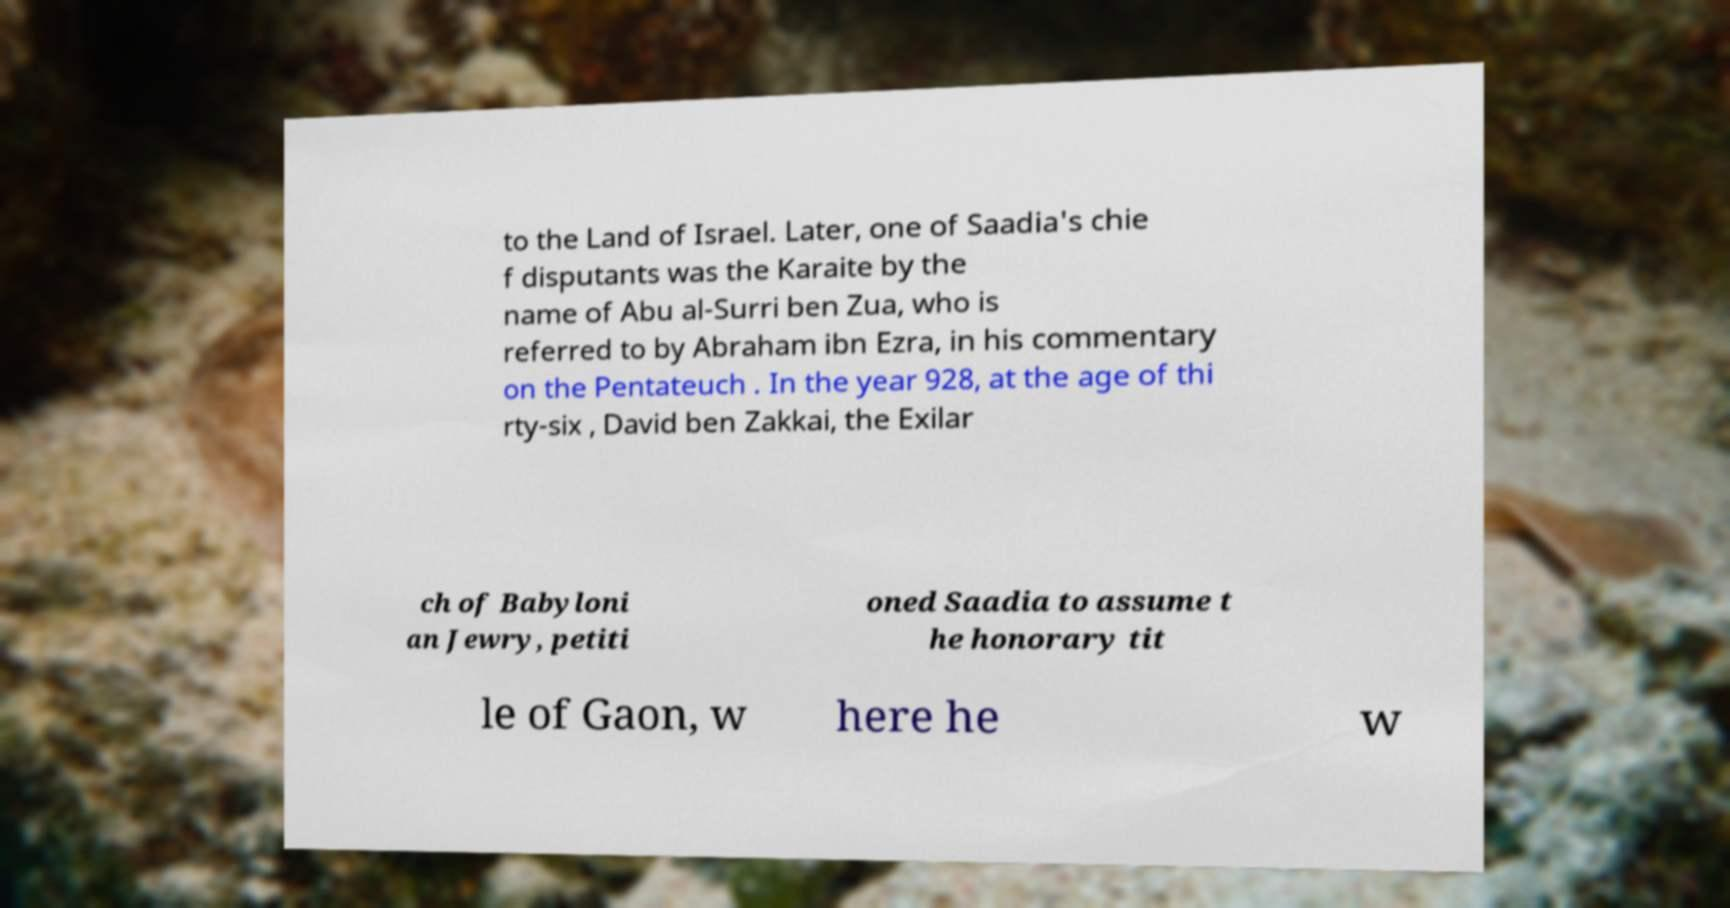Please read and relay the text visible in this image. What does it say? to the Land of Israel. Later, one of Saadia's chie f disputants was the Karaite by the name of Abu al-Surri ben Zua, who is referred to by Abraham ibn Ezra, in his commentary on the Pentateuch . In the year 928, at the age of thi rty-six , David ben Zakkai, the Exilar ch of Babyloni an Jewry, petiti oned Saadia to assume t he honorary tit le of Gaon, w here he w 